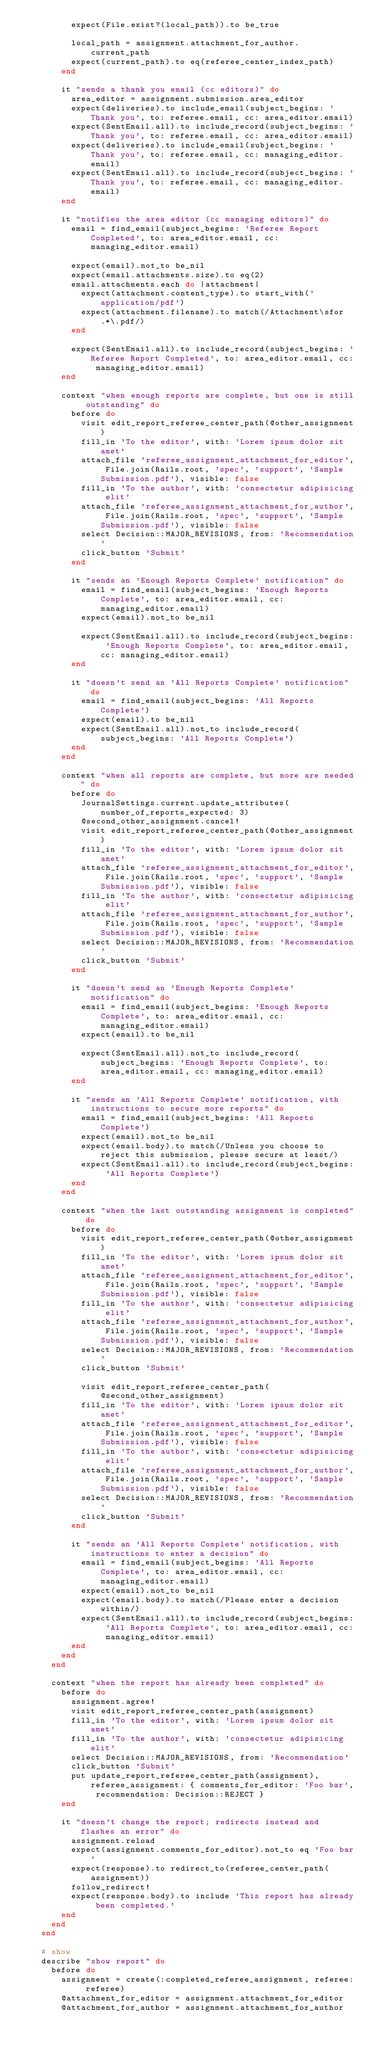<code> <loc_0><loc_0><loc_500><loc_500><_Ruby_>          expect(File.exist?(local_path)).to be_true

          local_path = assignment.attachment_for_author.current_path
          expect(current_path).to eq(referee_center_index_path)
        end

        it "sends a thank you email (cc editors)" do
          area_editor = assignment.submission.area_editor
          expect(deliveries).to include_email(subject_begins: 'Thank you', to: referee.email, cc: area_editor.email)
          expect(SentEmail.all).to include_record(subject_begins: 'Thank you', to: referee.email, cc: area_editor.email)
          expect(deliveries).to include_email(subject_begins: 'Thank you', to: referee.email, cc: managing_editor.email)
          expect(SentEmail.all).to include_record(subject_begins: 'Thank you', to: referee.email, cc: managing_editor.email)
        end

        it "notifies the area editor (cc managing editors)" do
          email = find_email(subject_begins: 'Referee Report Completed', to: area_editor.email, cc: managing_editor.email)

          expect(email).not_to be_nil
          expect(email.attachments.size).to eq(2)
          email.attachments.each do |attachment|
            expect(attachment.content_type).to start_with('application/pdf')
            expect(attachment.filename).to match(/Attachment\sfor.*\.pdf/)
          end

          expect(SentEmail.all).to include_record(subject_begins: 'Referee Report Completed', to: area_editor.email, cc: managing_editor.email)
        end

        context "when enough reports are complete, but one is still outstanding" do
          before do
            visit edit_report_referee_center_path(@other_assignment)
            fill_in 'To the editor', with: 'Lorem ipsum dolor sit amet'
            attach_file 'referee_assignment_attachment_for_editor', File.join(Rails.root, 'spec', 'support', 'Sample Submission.pdf'), visible: false
            fill_in 'To the author', with: 'consectetur adipisicing elit'
            attach_file 'referee_assignment_attachment_for_author', File.join(Rails.root, 'spec', 'support', 'Sample Submission.pdf'), visible: false
            select Decision::MAJOR_REVISIONS, from: 'Recommendation'
            click_button 'Submit'
          end

          it "sends an 'Enough Reports Complete' notification" do
            email = find_email(subject_begins: 'Enough Reports Complete', to: area_editor.email, cc: managing_editor.email)
            expect(email).not_to be_nil

            expect(SentEmail.all).to include_record(subject_begins: 'Enough Reports Complete', to: area_editor.email, cc: managing_editor.email)
          end

          it "doesn't send an 'All Reports Complete' notification" do
            email = find_email(subject_begins: 'All Reports Complete')
            expect(email).to be_nil
            expect(SentEmail.all).not_to include_record(subject_begins: 'All Reports Complete')
          end
        end

        context "when all reports are complete, but more are needed" do
          before do
            JournalSettings.current.update_attributes(number_of_reports_expected: 3)
            @second_other_assignment.cancel!
            visit edit_report_referee_center_path(@other_assignment)
            fill_in 'To the editor', with: 'Lorem ipsum dolor sit amet'
            attach_file 'referee_assignment_attachment_for_editor', File.join(Rails.root, 'spec', 'support', 'Sample Submission.pdf'), visible: false
            fill_in 'To the author', with: 'consectetur adipisicing elit'
            attach_file 'referee_assignment_attachment_for_author', File.join(Rails.root, 'spec', 'support', 'Sample Submission.pdf'), visible: false
            select Decision::MAJOR_REVISIONS, from: 'Recommendation'
            click_button 'Submit'
          end

          it "doesn't send an 'Enough Reports Complete' notification" do
            email = find_email(subject_begins: 'Enough Reports Complete', to: area_editor.email, cc: managing_editor.email)
            expect(email).to be_nil

            expect(SentEmail.all).not_to include_record(subject_begins: 'Enough Reports Complete', to: area_editor.email, cc: managing_editor.email)
          end

          it "sends an 'All Reports Complete' notification, with instructions to secure more reports" do
            email = find_email(subject_begins: 'All Reports Complete')
            expect(email).not_to be_nil
            expect(email.body).to match(/Unless you choose to reject this submission, please secure at least/)
            expect(SentEmail.all).to include_record(subject_begins: 'All Reports Complete')
          end
        end

        context "when the last outstanding assignment is completed" do
          before do
            visit edit_report_referee_center_path(@other_assignment)
            fill_in 'To the editor', with: 'Lorem ipsum dolor sit amet'
            attach_file 'referee_assignment_attachment_for_editor', File.join(Rails.root, 'spec', 'support', 'Sample Submission.pdf'), visible: false
            fill_in 'To the author', with: 'consectetur adipisicing elit'
            attach_file 'referee_assignment_attachment_for_author', File.join(Rails.root, 'spec', 'support', 'Sample Submission.pdf'), visible: false
            select Decision::MAJOR_REVISIONS, from: 'Recommendation'
            click_button 'Submit'

            visit edit_report_referee_center_path(@second_other_assignment)
            fill_in 'To the editor', with: 'Lorem ipsum dolor sit amet'
            attach_file 'referee_assignment_attachment_for_editor', File.join(Rails.root, 'spec', 'support', 'Sample Submission.pdf'), visible: false
            fill_in 'To the author', with: 'consectetur adipisicing elit'
            attach_file 'referee_assignment_attachment_for_author', File.join(Rails.root, 'spec', 'support', 'Sample Submission.pdf'), visible: false
            select Decision::MAJOR_REVISIONS, from: 'Recommendation'
            click_button 'Submit'
          end

          it "sends an 'All Reports Complete' notification, with instructions to enter a decision" do
            email = find_email(subject_begins: 'All Reports Complete', to: area_editor.email, cc: managing_editor.email)
            expect(email).not_to be_nil
            expect(email.body).to match(/Please enter a decision within/)
            expect(SentEmail.all).to include_record(subject_begins: 'All Reports Complete', to: area_editor.email, cc: managing_editor.email)
          end
        end
      end

      context "when the report has already been completed" do
        before do
          assignment.agree!
          visit edit_report_referee_center_path(assignment)
          fill_in 'To the editor', with: 'Lorem ipsum dolor sit amet'
          fill_in 'To the author', with: 'consectetur adipisicing elit'
          select Decision::MAJOR_REVISIONS, from: 'Recommendation'
          click_button 'Submit'
          put update_report_referee_center_path(assignment), referee_assignment: { comments_for_editor: 'Foo bar', recommendation: Decision::REJECT }
        end

        it "doesn't change the report; redirects instead and flashes an error" do
          assignment.reload
          expect(assignment.comments_for_editor).not_to eq 'Foo bar'
          expect(response).to redirect_to(referee_center_path(assignment))
          follow_redirect!
          expect(response.body).to include 'This report has already been completed.'
        end
      end
    end

    # show
    describe "show report" do
      before do
        assignment = create(:completed_referee_assignment, referee: referee)
        @attachment_for_editor = assignment.attachment_for_editor
        @attachment_for_author = assignment.attachment_for_author</code> 